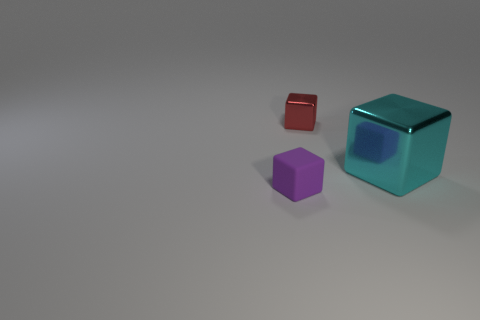Subtract all red metallic cubes. How many cubes are left? 2 Add 2 blocks. How many objects exist? 5 Subtract 2 cubes. How many cubes are left? 1 Subtract all brown blocks. Subtract all blue balls. How many blocks are left? 3 Subtract all yellow shiny balls. Subtract all shiny things. How many objects are left? 1 Add 3 metallic things. How many metallic things are left? 5 Add 3 large blue metal cylinders. How many large blue metal cylinders exist? 3 Subtract 0 red balls. How many objects are left? 3 